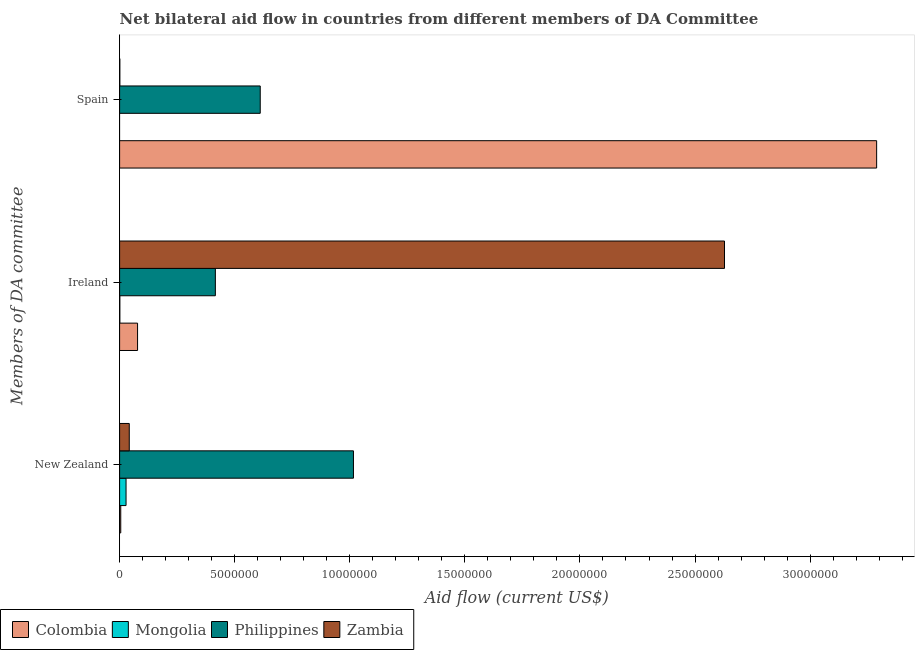How many different coloured bars are there?
Provide a succinct answer. 4. How many groups of bars are there?
Provide a short and direct response. 3. Are the number of bars on each tick of the Y-axis equal?
Give a very brief answer. No. How many bars are there on the 1st tick from the bottom?
Make the answer very short. 4. What is the label of the 2nd group of bars from the top?
Ensure brevity in your answer.  Ireland. What is the amount of aid provided by new zealand in Colombia?
Ensure brevity in your answer.  5.00e+04. Across all countries, what is the maximum amount of aid provided by spain?
Provide a succinct answer. 3.29e+07. In which country was the amount of aid provided by ireland maximum?
Your answer should be compact. Zambia. What is the total amount of aid provided by new zealand in the graph?
Provide a succinct answer. 1.09e+07. What is the difference between the amount of aid provided by ireland in Colombia and that in Zambia?
Provide a succinct answer. -2.55e+07. What is the difference between the amount of aid provided by ireland in Philippines and the amount of aid provided by spain in Colombia?
Provide a succinct answer. -2.87e+07. What is the average amount of aid provided by spain per country?
Keep it short and to the point. 9.75e+06. What is the difference between the amount of aid provided by spain and amount of aid provided by ireland in Philippines?
Give a very brief answer. 1.95e+06. What is the ratio of the amount of aid provided by new zealand in Colombia to that in Mongolia?
Your answer should be compact. 0.18. What is the difference between the highest and the second highest amount of aid provided by ireland?
Provide a succinct answer. 2.21e+07. What is the difference between the highest and the lowest amount of aid provided by ireland?
Give a very brief answer. 2.63e+07. In how many countries, is the amount of aid provided by new zealand greater than the average amount of aid provided by new zealand taken over all countries?
Offer a terse response. 1. Is the sum of the amount of aid provided by ireland in Zambia and Colombia greater than the maximum amount of aid provided by spain across all countries?
Offer a terse response. No. How many countries are there in the graph?
Offer a very short reply. 4. Are the values on the major ticks of X-axis written in scientific E-notation?
Your answer should be very brief. No. Does the graph contain any zero values?
Make the answer very short. Yes. Where does the legend appear in the graph?
Provide a short and direct response. Bottom left. What is the title of the graph?
Make the answer very short. Net bilateral aid flow in countries from different members of DA Committee. Does "Myanmar" appear as one of the legend labels in the graph?
Make the answer very short. No. What is the label or title of the X-axis?
Provide a short and direct response. Aid flow (current US$). What is the label or title of the Y-axis?
Keep it short and to the point. Members of DA committee. What is the Aid flow (current US$) in Colombia in New Zealand?
Your answer should be very brief. 5.00e+04. What is the Aid flow (current US$) of Philippines in New Zealand?
Offer a very short reply. 1.02e+07. What is the Aid flow (current US$) of Zambia in New Zealand?
Offer a terse response. 4.20e+05. What is the Aid flow (current US$) of Colombia in Ireland?
Provide a succinct answer. 7.80e+05. What is the Aid flow (current US$) in Philippines in Ireland?
Offer a very short reply. 4.16e+06. What is the Aid flow (current US$) of Zambia in Ireland?
Your answer should be very brief. 2.63e+07. What is the Aid flow (current US$) in Colombia in Spain?
Keep it short and to the point. 3.29e+07. What is the Aid flow (current US$) of Philippines in Spain?
Provide a short and direct response. 6.11e+06. Across all Members of DA committee, what is the maximum Aid flow (current US$) in Colombia?
Give a very brief answer. 3.29e+07. Across all Members of DA committee, what is the maximum Aid flow (current US$) of Philippines?
Offer a terse response. 1.02e+07. Across all Members of DA committee, what is the maximum Aid flow (current US$) in Zambia?
Provide a succinct answer. 2.63e+07. Across all Members of DA committee, what is the minimum Aid flow (current US$) of Colombia?
Provide a succinct answer. 5.00e+04. Across all Members of DA committee, what is the minimum Aid flow (current US$) in Philippines?
Your answer should be very brief. 4.16e+06. What is the total Aid flow (current US$) of Colombia in the graph?
Give a very brief answer. 3.37e+07. What is the total Aid flow (current US$) in Philippines in the graph?
Make the answer very short. 2.04e+07. What is the total Aid flow (current US$) of Zambia in the graph?
Offer a terse response. 2.67e+07. What is the difference between the Aid flow (current US$) of Colombia in New Zealand and that in Ireland?
Offer a terse response. -7.30e+05. What is the difference between the Aid flow (current US$) of Mongolia in New Zealand and that in Ireland?
Your answer should be compact. 2.70e+05. What is the difference between the Aid flow (current US$) in Zambia in New Zealand and that in Ireland?
Your answer should be very brief. -2.59e+07. What is the difference between the Aid flow (current US$) in Colombia in New Zealand and that in Spain?
Offer a very short reply. -3.28e+07. What is the difference between the Aid flow (current US$) of Philippines in New Zealand and that in Spain?
Your answer should be compact. 4.05e+06. What is the difference between the Aid flow (current US$) of Zambia in New Zealand and that in Spain?
Offer a very short reply. 4.10e+05. What is the difference between the Aid flow (current US$) in Colombia in Ireland and that in Spain?
Ensure brevity in your answer.  -3.21e+07. What is the difference between the Aid flow (current US$) of Philippines in Ireland and that in Spain?
Your response must be concise. -1.95e+06. What is the difference between the Aid flow (current US$) in Zambia in Ireland and that in Spain?
Provide a succinct answer. 2.63e+07. What is the difference between the Aid flow (current US$) in Colombia in New Zealand and the Aid flow (current US$) in Mongolia in Ireland?
Keep it short and to the point. 4.00e+04. What is the difference between the Aid flow (current US$) of Colombia in New Zealand and the Aid flow (current US$) of Philippines in Ireland?
Give a very brief answer. -4.11e+06. What is the difference between the Aid flow (current US$) in Colombia in New Zealand and the Aid flow (current US$) in Zambia in Ireland?
Provide a succinct answer. -2.62e+07. What is the difference between the Aid flow (current US$) of Mongolia in New Zealand and the Aid flow (current US$) of Philippines in Ireland?
Ensure brevity in your answer.  -3.88e+06. What is the difference between the Aid flow (current US$) of Mongolia in New Zealand and the Aid flow (current US$) of Zambia in Ireland?
Your answer should be compact. -2.60e+07. What is the difference between the Aid flow (current US$) of Philippines in New Zealand and the Aid flow (current US$) of Zambia in Ireland?
Your response must be concise. -1.61e+07. What is the difference between the Aid flow (current US$) in Colombia in New Zealand and the Aid flow (current US$) in Philippines in Spain?
Ensure brevity in your answer.  -6.06e+06. What is the difference between the Aid flow (current US$) of Mongolia in New Zealand and the Aid flow (current US$) of Philippines in Spain?
Keep it short and to the point. -5.83e+06. What is the difference between the Aid flow (current US$) in Philippines in New Zealand and the Aid flow (current US$) in Zambia in Spain?
Your answer should be compact. 1.02e+07. What is the difference between the Aid flow (current US$) of Colombia in Ireland and the Aid flow (current US$) of Philippines in Spain?
Offer a very short reply. -5.33e+06. What is the difference between the Aid flow (current US$) of Colombia in Ireland and the Aid flow (current US$) of Zambia in Spain?
Your answer should be very brief. 7.70e+05. What is the difference between the Aid flow (current US$) in Mongolia in Ireland and the Aid flow (current US$) in Philippines in Spain?
Give a very brief answer. -6.10e+06. What is the difference between the Aid flow (current US$) of Philippines in Ireland and the Aid flow (current US$) of Zambia in Spain?
Offer a terse response. 4.15e+06. What is the average Aid flow (current US$) in Colombia per Members of DA committee?
Your answer should be very brief. 1.12e+07. What is the average Aid flow (current US$) of Mongolia per Members of DA committee?
Your answer should be compact. 9.67e+04. What is the average Aid flow (current US$) in Philippines per Members of DA committee?
Provide a succinct answer. 6.81e+06. What is the average Aid flow (current US$) of Zambia per Members of DA committee?
Offer a terse response. 8.90e+06. What is the difference between the Aid flow (current US$) in Colombia and Aid flow (current US$) in Mongolia in New Zealand?
Your answer should be very brief. -2.30e+05. What is the difference between the Aid flow (current US$) of Colombia and Aid flow (current US$) of Philippines in New Zealand?
Provide a succinct answer. -1.01e+07. What is the difference between the Aid flow (current US$) in Colombia and Aid flow (current US$) in Zambia in New Zealand?
Offer a very short reply. -3.70e+05. What is the difference between the Aid flow (current US$) in Mongolia and Aid flow (current US$) in Philippines in New Zealand?
Offer a very short reply. -9.88e+06. What is the difference between the Aid flow (current US$) of Mongolia and Aid flow (current US$) of Zambia in New Zealand?
Make the answer very short. -1.40e+05. What is the difference between the Aid flow (current US$) in Philippines and Aid flow (current US$) in Zambia in New Zealand?
Make the answer very short. 9.74e+06. What is the difference between the Aid flow (current US$) of Colombia and Aid flow (current US$) of Mongolia in Ireland?
Give a very brief answer. 7.70e+05. What is the difference between the Aid flow (current US$) in Colombia and Aid flow (current US$) in Philippines in Ireland?
Offer a terse response. -3.38e+06. What is the difference between the Aid flow (current US$) in Colombia and Aid flow (current US$) in Zambia in Ireland?
Offer a very short reply. -2.55e+07. What is the difference between the Aid flow (current US$) in Mongolia and Aid flow (current US$) in Philippines in Ireland?
Make the answer very short. -4.15e+06. What is the difference between the Aid flow (current US$) of Mongolia and Aid flow (current US$) of Zambia in Ireland?
Your response must be concise. -2.63e+07. What is the difference between the Aid flow (current US$) of Philippines and Aid flow (current US$) of Zambia in Ireland?
Your answer should be compact. -2.21e+07. What is the difference between the Aid flow (current US$) in Colombia and Aid flow (current US$) in Philippines in Spain?
Give a very brief answer. 2.68e+07. What is the difference between the Aid flow (current US$) in Colombia and Aid flow (current US$) in Zambia in Spain?
Give a very brief answer. 3.29e+07. What is the difference between the Aid flow (current US$) of Philippines and Aid flow (current US$) of Zambia in Spain?
Give a very brief answer. 6.10e+06. What is the ratio of the Aid flow (current US$) in Colombia in New Zealand to that in Ireland?
Make the answer very short. 0.06. What is the ratio of the Aid flow (current US$) of Mongolia in New Zealand to that in Ireland?
Your response must be concise. 28. What is the ratio of the Aid flow (current US$) in Philippines in New Zealand to that in Ireland?
Your answer should be very brief. 2.44. What is the ratio of the Aid flow (current US$) of Zambia in New Zealand to that in Ireland?
Keep it short and to the point. 0.02. What is the ratio of the Aid flow (current US$) in Colombia in New Zealand to that in Spain?
Provide a short and direct response. 0. What is the ratio of the Aid flow (current US$) in Philippines in New Zealand to that in Spain?
Make the answer very short. 1.66. What is the ratio of the Aid flow (current US$) of Colombia in Ireland to that in Spain?
Offer a very short reply. 0.02. What is the ratio of the Aid flow (current US$) of Philippines in Ireland to that in Spain?
Keep it short and to the point. 0.68. What is the ratio of the Aid flow (current US$) in Zambia in Ireland to that in Spain?
Provide a succinct answer. 2628. What is the difference between the highest and the second highest Aid flow (current US$) of Colombia?
Your answer should be compact. 3.21e+07. What is the difference between the highest and the second highest Aid flow (current US$) in Philippines?
Offer a very short reply. 4.05e+06. What is the difference between the highest and the second highest Aid flow (current US$) in Zambia?
Make the answer very short. 2.59e+07. What is the difference between the highest and the lowest Aid flow (current US$) in Colombia?
Your answer should be compact. 3.28e+07. What is the difference between the highest and the lowest Aid flow (current US$) of Mongolia?
Keep it short and to the point. 2.80e+05. What is the difference between the highest and the lowest Aid flow (current US$) of Zambia?
Offer a terse response. 2.63e+07. 